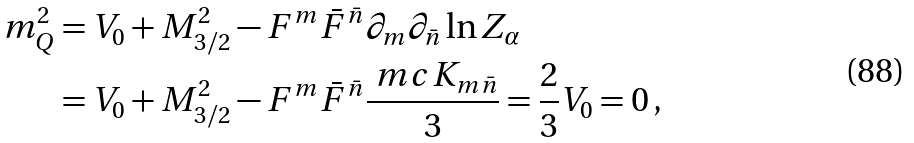Convert formula to latex. <formula><loc_0><loc_0><loc_500><loc_500>m _ { Q } ^ { 2 } & = V _ { 0 } + M _ { 3 / 2 } ^ { 2 } - F ^ { m } \bar { F } ^ { \bar { n } } \partial _ { m } \partial _ { \bar { n } } \ln { Z } _ { \alpha } \\ & = V _ { 0 } + M _ { 3 / 2 } ^ { 2 } - F ^ { m } \bar { F } ^ { \bar { n } } \frac { \ m c { K } _ { m \bar { n } } } { 3 } = \frac { 2 } { 3 } V _ { 0 } = 0 \, ,</formula> 